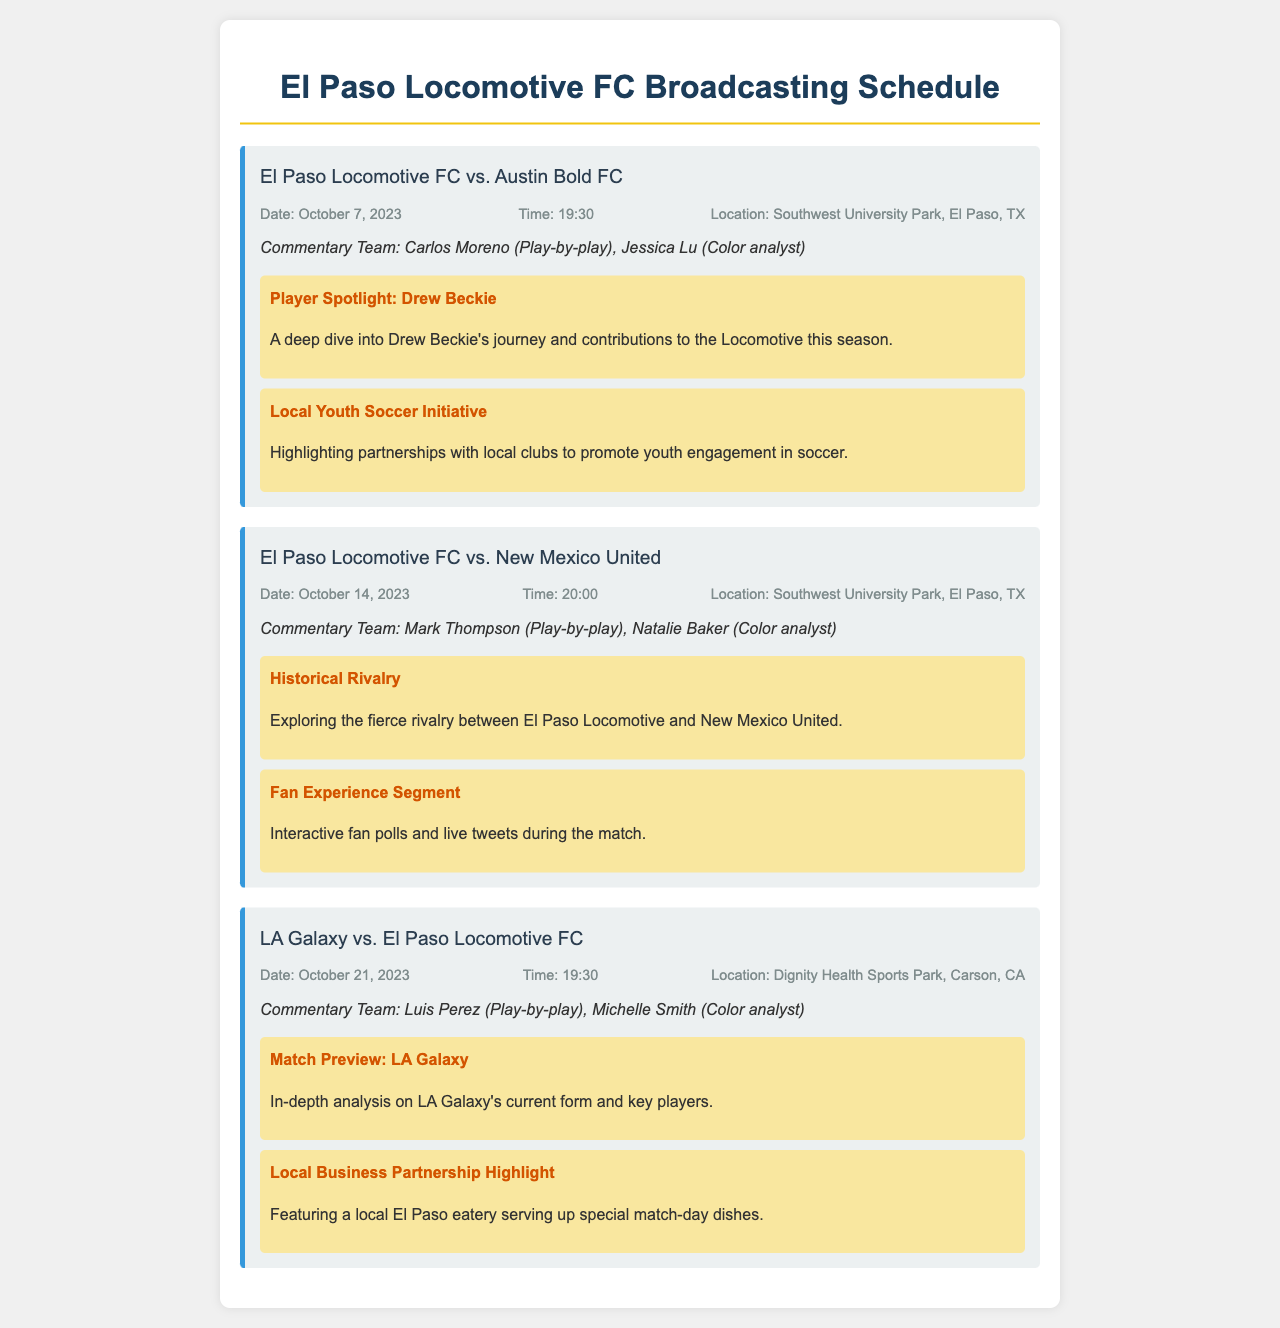What is the date of the match against Austin Bold FC? The date of the match against Austin Bold FC is mentioned in the match card for that game.
Answer: October 7, 2023 Who is the play-by-play commentator for the match against New Mexico United? The play-by-play commentator for the match against New Mexico United is listed in that match card's commentary team section.
Answer: Mark Thompson How many matches are listed in the broadcasting schedule? The total number of matches is counted from the match card section of the document.
Answer: Three What feature highlights Drew Beckie's contributions? The feature discussing Drew Beckie's contributions is labeled in the special features section of the match card.
Answer: Player Spotlight: Drew Beckie What time does the match against LA Galaxy start? The start time for the match against LA Galaxy is found in the match card details.
Answer: 19:30 Which team is the local rivalry against in the match on October 14, 2023? The local rivalry mentioned in the context of the match card is identified alongside the teams involved.
Answer: New Mexico United What is the location for the match against Austin Bold FC? The location of the match is specified in the match details section of the document for that game.
Answer: Southwest University Park, El Paso, TX What kind of segment features interactive fan polls during the match? The type of segment is indicated in the special features section of the relevant match card.
Answer: Fan Experience Segment 